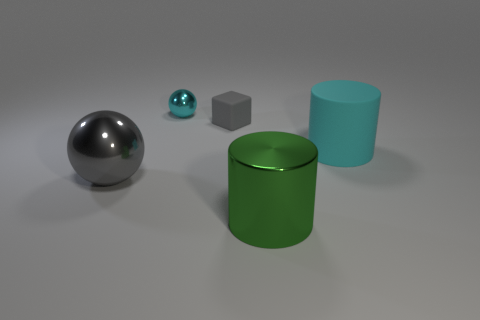Are there fewer tiny yellow matte cylinders than gray cubes?
Give a very brief answer. Yes. What is the color of the other big thing that is the same shape as the green metal thing?
Provide a succinct answer. Cyan. Is there any other thing that is the same shape as the small gray rubber thing?
Keep it short and to the point. No. Is the number of purple metal spheres greater than the number of green metal cylinders?
Offer a very short reply. No. What number of other objects are the same material as the tiny cube?
Your answer should be compact. 1. There is a gray object to the right of the cyan sphere that is left of the large thing right of the large green metallic object; what is its shape?
Keep it short and to the point. Cube. Is the number of small gray cubes that are on the left side of the gray ball less than the number of small metallic things that are in front of the gray rubber thing?
Provide a short and direct response. No. Are there any small rubber things that have the same color as the big ball?
Give a very brief answer. Yes. Are the gray block and the ball that is on the right side of the big gray shiny ball made of the same material?
Give a very brief answer. No. There is a metal sphere behind the big metal sphere; is there a tiny metal object that is behind it?
Your answer should be compact. No. 